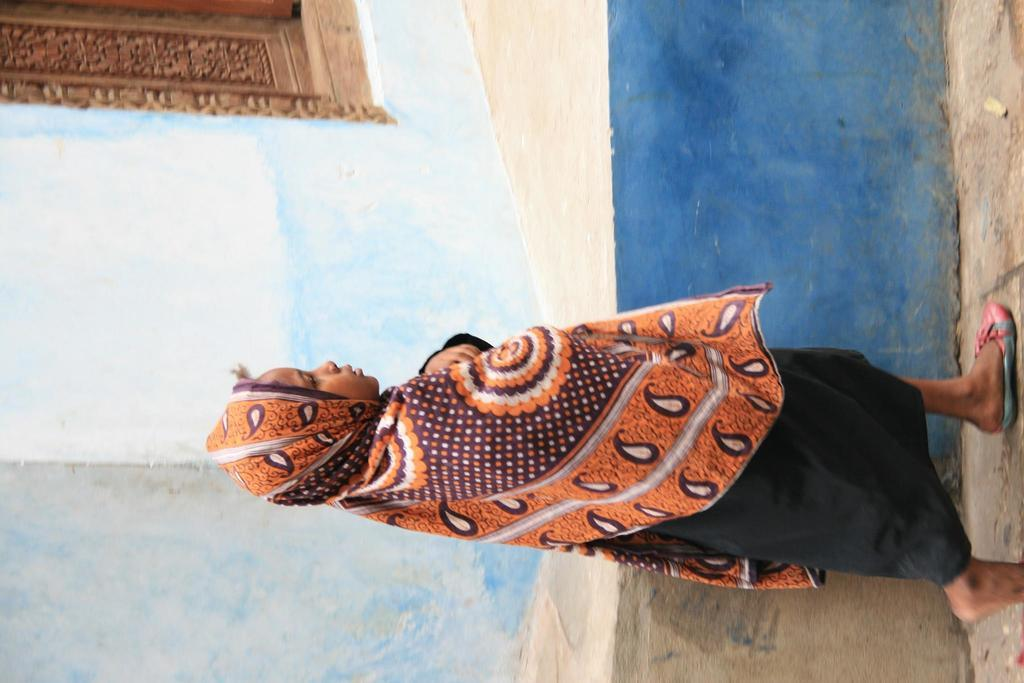Who is the main subject in the image? There is a girl in the image. What is the girl wearing in the image? The girl is wearing a scarf in the image. What is the girl doing in the image? The girl is walking beside a building in the image. What can be seen in the middle of the building? There is a door in the middle of the building. How many dimes can be seen on the girl's seat in the image? There is no mention of dimes or a seat in the image, so it is not possible to answer that question. 